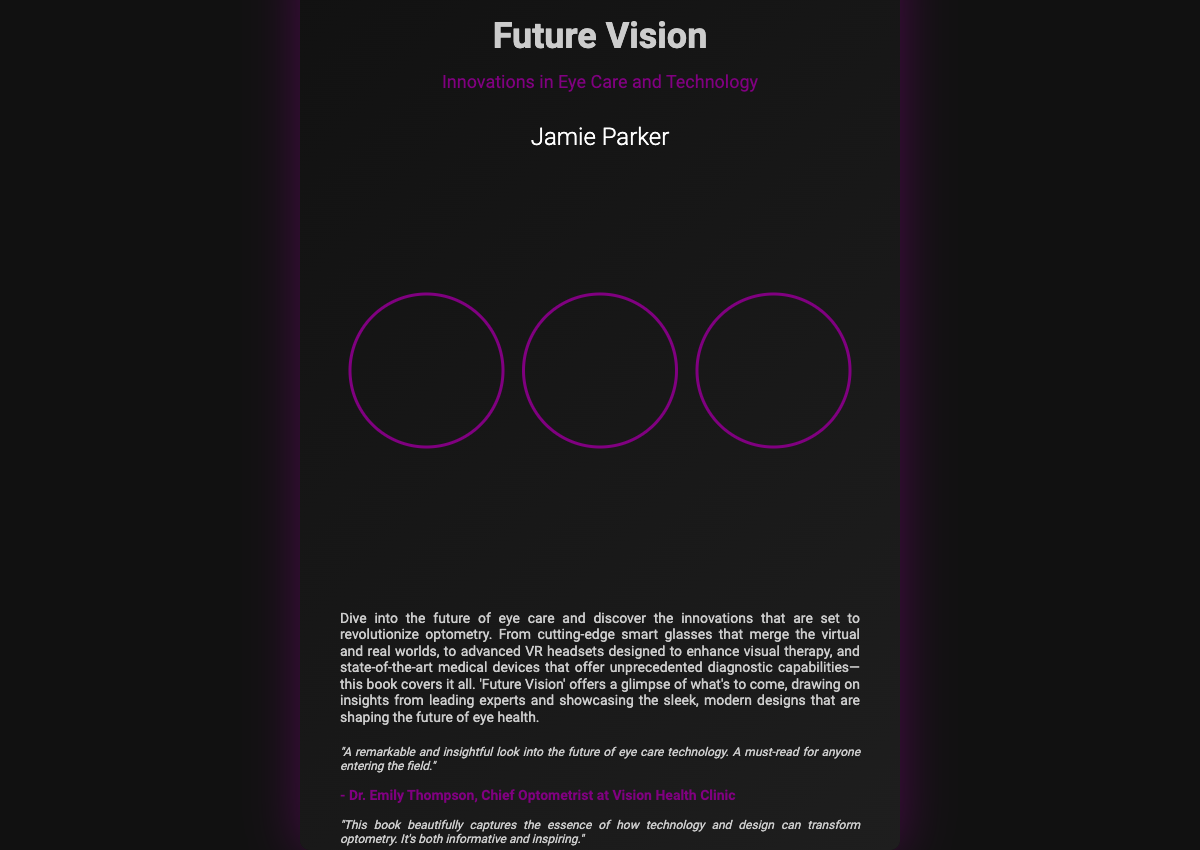What is the title of the book? The title of the book is prominently displayed at the top of the cover.
Answer: Future Vision Who is the author of the book? The author's name is listed below the title on the cover.
Answer: Jamie Parker What are the three types of images featured on the book cover? The images represent innovative technologies related to eye care, specifically mentioned in the content.
Answer: Smart glasses, VR headsets, medical devices What is the color theme used in the book cover design? The description highlights the metallic colors used throughout the cover design.
Answer: Silver, purple, black Which statement describes the book's content? The back cover description summarizes the book's focus on innovations in eye care technology.
Answer: Innovations that are set to revolutionize optometry What is a testimonial's author's role mentioned in the document? The document provides a background on one of the authors of the testimonial, revealing their professional title.
Answer: Chief Optometrist Why might the book be considered essential for someone entering the field of optometry? The testimonials reflect on the book's insightful content and relevance to future professionals in eye care.
Answer: Remarkable and insightful look into the future What type of aesthetic is used in the book cover? The aesthetic describes the overall visual style and design attributes of the cover.
Answer: Minimalist 